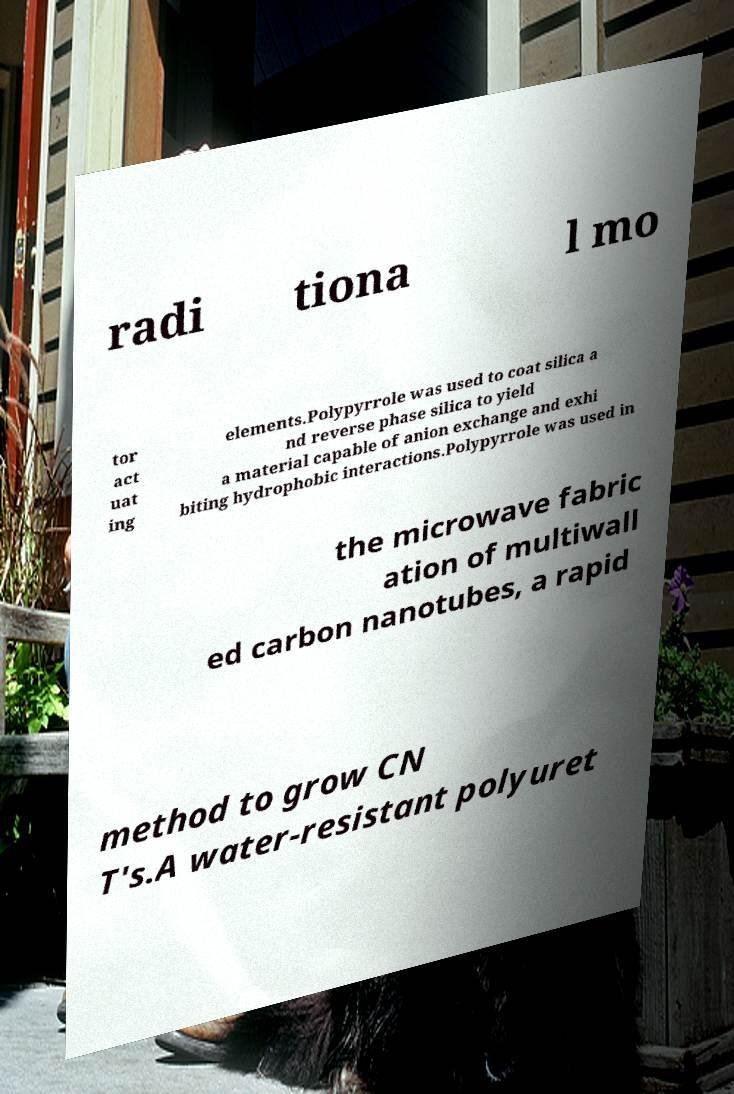Could you assist in decoding the text presented in this image and type it out clearly? radi tiona l mo tor act uat ing elements.Polypyrrole was used to coat silica a nd reverse phase silica to yield a material capable of anion exchange and exhi biting hydrophobic interactions.Polypyrrole was used in the microwave fabric ation of multiwall ed carbon nanotubes, a rapid method to grow CN T's.A water-resistant polyuret 